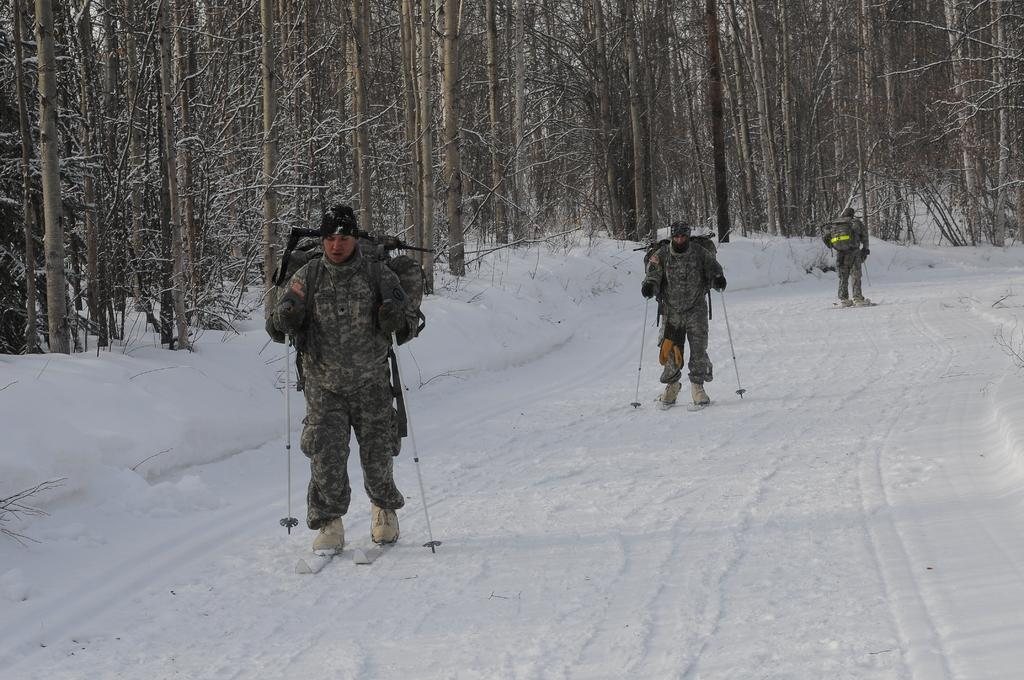What activity are the people in the image engaged in? The people in the image are skiing. What equipment are they using for skiing? The people are using skis and holding sticks, which are likely ski poles. What else are the people carrying while skiing? The people are carrying bags. What can be seen in the background of the image? There are trees in the background of the image. What type of sheet is being used by the people to ski in the image? There is no sheet visible in the image; the people are using skis for skiing. 